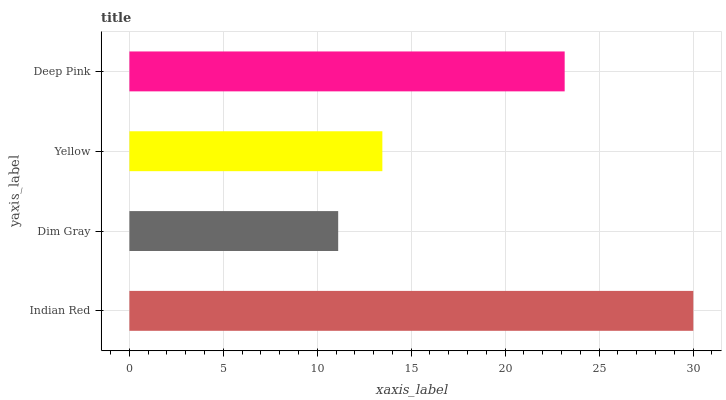Is Dim Gray the minimum?
Answer yes or no. Yes. Is Indian Red the maximum?
Answer yes or no. Yes. Is Yellow the minimum?
Answer yes or no. No. Is Yellow the maximum?
Answer yes or no. No. Is Yellow greater than Dim Gray?
Answer yes or no. Yes. Is Dim Gray less than Yellow?
Answer yes or no. Yes. Is Dim Gray greater than Yellow?
Answer yes or no. No. Is Yellow less than Dim Gray?
Answer yes or no. No. Is Deep Pink the high median?
Answer yes or no. Yes. Is Yellow the low median?
Answer yes or no. Yes. Is Dim Gray the high median?
Answer yes or no. No. Is Deep Pink the low median?
Answer yes or no. No. 